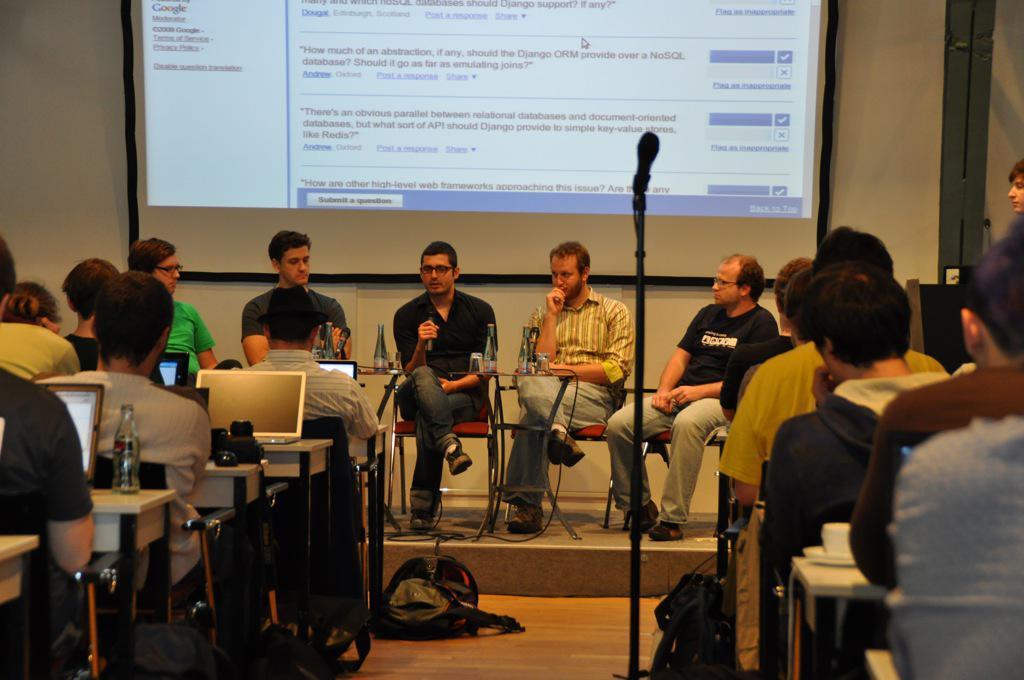In one or two sentences, can you explain what this image depicts? This is a picture of a group of people who are sitting on the chairs in front of a desk on which there are some laptops, water bottles and there is a mike and a bag on the floor. 